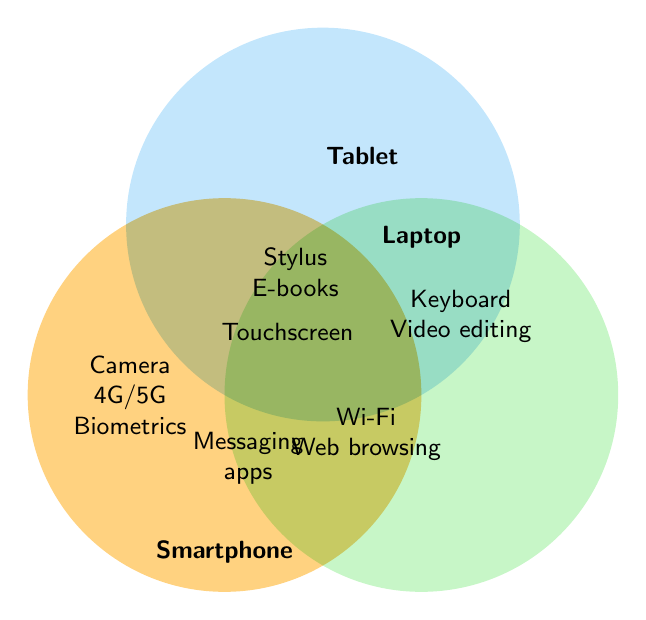What features are exclusive to smartphones according to the Venn diagram? The areas exclusive to smartphones list features such as Camera, 4G/5G, and Biometrics.
Answer: Camera, 4G/5G, Biometrics What features do both smartphones and tablets have in common? The overlapping area between smartphones and tablets includes Messaging apps and Touchscreen.
Answer: Messaging apps, Touchscreen Which feature is common to all three devices: smartphone, tablet, and laptop? The central overlapping area where all three circles intersect has the feature Wi-Fi.
Answer: Wi-Fi What features are exclusive to laptops? The part of the Venn diagram exclusive to laptops includes Keyboard and Video editing.
Answer: Keyboard, Video editing Which two devices share the feature "Web browsing"? The overlapping area containing Web browsing is between smartphone and laptop.
Answer: Smartphone, Laptop What features do tablets and laptops have in common? The overlapping area between tablets and laptops has Stylus and E-books.
Answer: Stylus, E-books What is the feature common to smartphones and laptops that is not shared with tablets? The diagram shows Web browsing as the common feature between smartphones and laptops but not with tablets.
Answer: Web browsing List all the features for which tablets and smartphones overlap. The overlap area between tablets and smartphones shows Messaging apps, Touchscreen, and Portable.
Answer: Messaging apps, Touchscreen, Portable Which features are unique to tablets? The Venn diagram shows the features exclusive to tablets as Media consumption and Book reading.
Answer: Media consumption, Book reading How many features are common between all three devices? The central region shows the overlapping feature is Wi-Fi, which is the only common feature for all three devices.
Answer: 1 